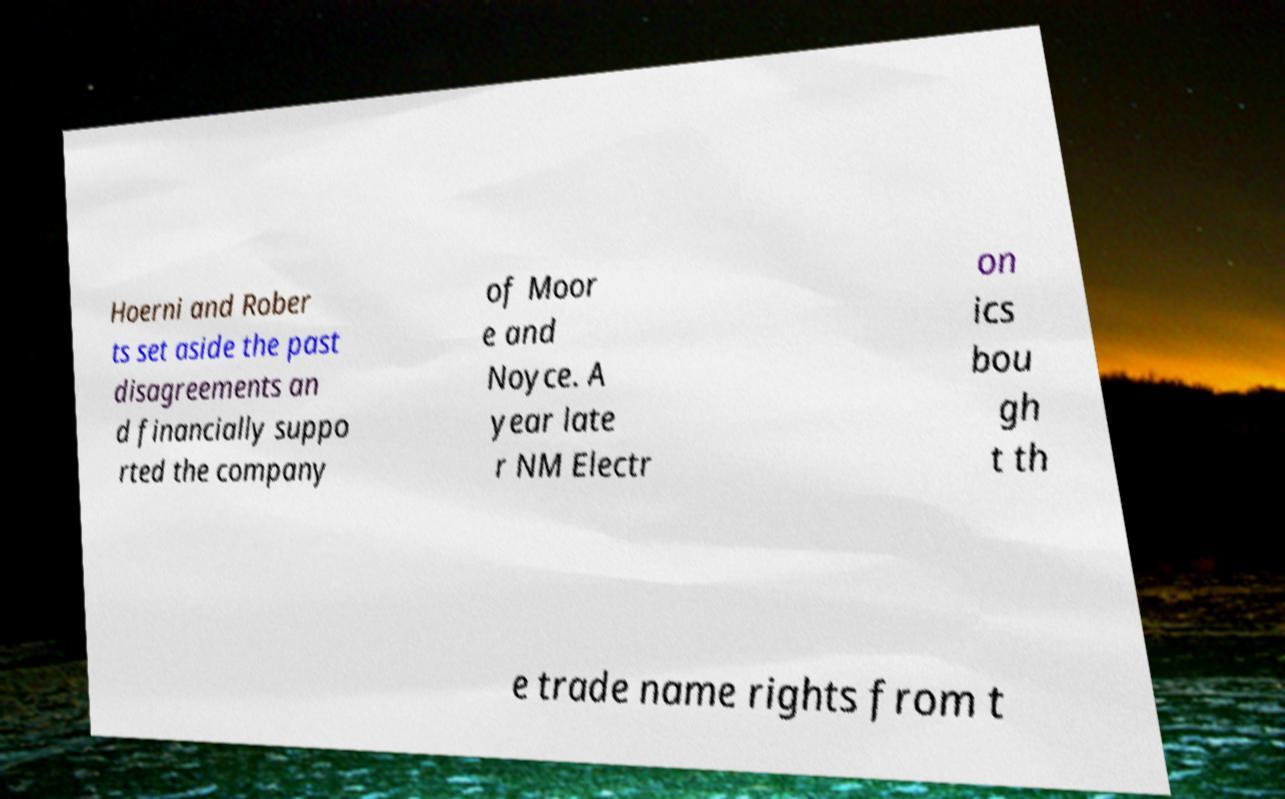I need the written content from this picture converted into text. Can you do that? Hoerni and Rober ts set aside the past disagreements an d financially suppo rted the company of Moor e and Noyce. A year late r NM Electr on ics bou gh t th e trade name rights from t 